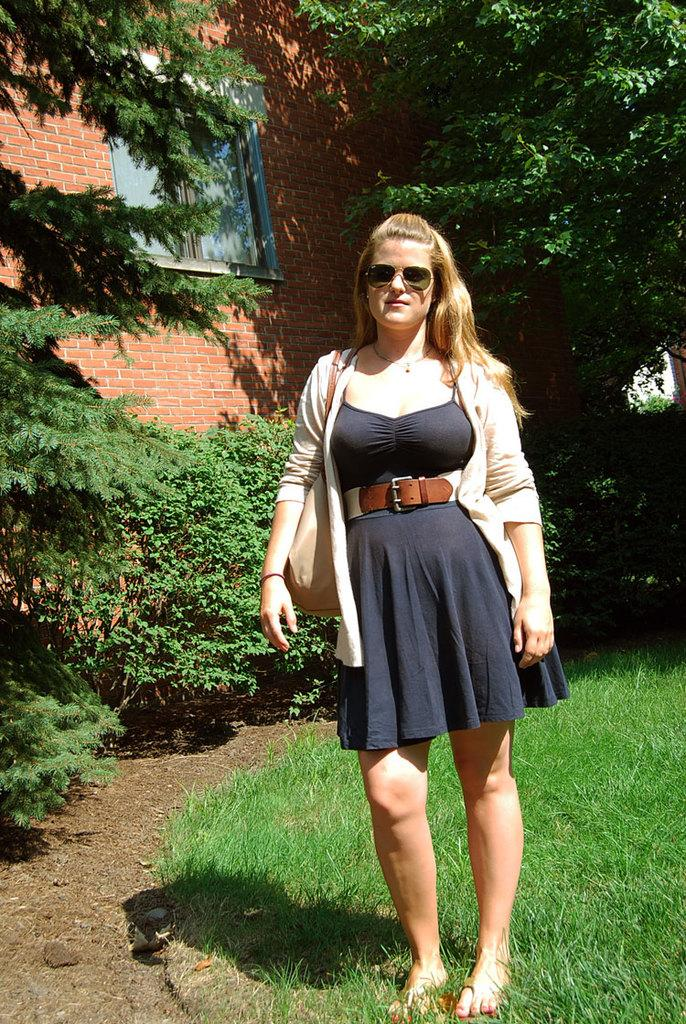What is the person in the image wearing on their face? The person in the image is wearing spectacles. What can be seen beneath the person's feet in the image? The ground is visible in the image. What type of vegetation is present in the image? There is grass, plants, and trees in the image. What architectural feature can be seen in the image? There is a wall with windows in the image. What type of butter is being used to decorate the plants in the image? There is no butter present in the image; it features a person wearing spectacles, grass, plants, trees, and a wall with windows. 